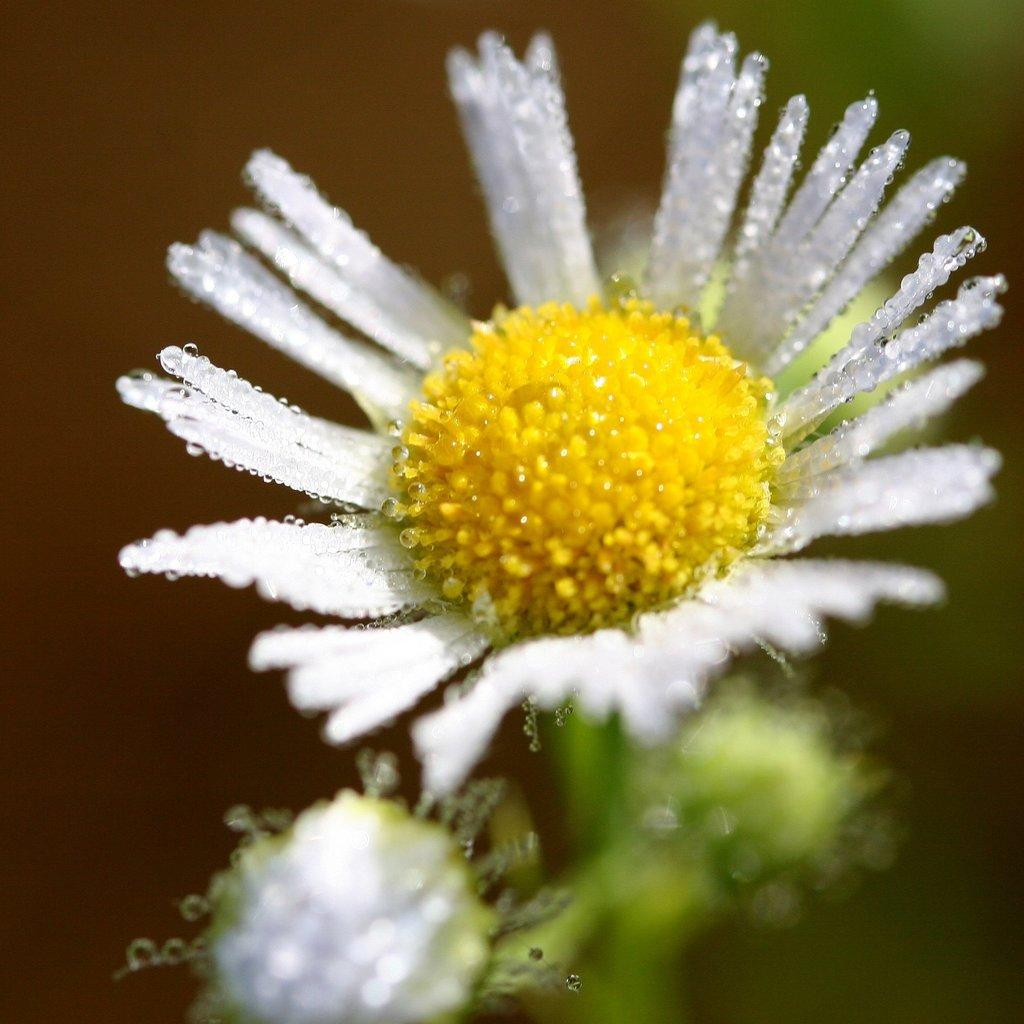What is the main subject of the image? There is a flower in the image. Can you describe the background of the image? The background of the image is blurry. Reasoning: Let's think step by identifying the main subject and describing the background. We start by mentioning the flower as the main subject, and then we describe the background as blurry. We avoid asking questions that cannot be answered definitively with the given facts. Absurd Question/Answer: What type of juice is being poured by the boy in the image? There is no boy or juice present in the image; it only features a flower with a blurry background. 